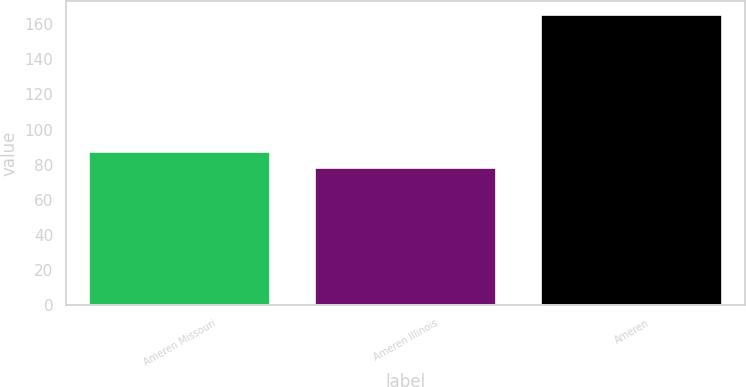Convert chart. <chart><loc_0><loc_0><loc_500><loc_500><bar_chart><fcel>Ameren Missouri<fcel>Ameren Illinois<fcel>Ameren<nl><fcel>87<fcel>78<fcel>165<nl></chart> 